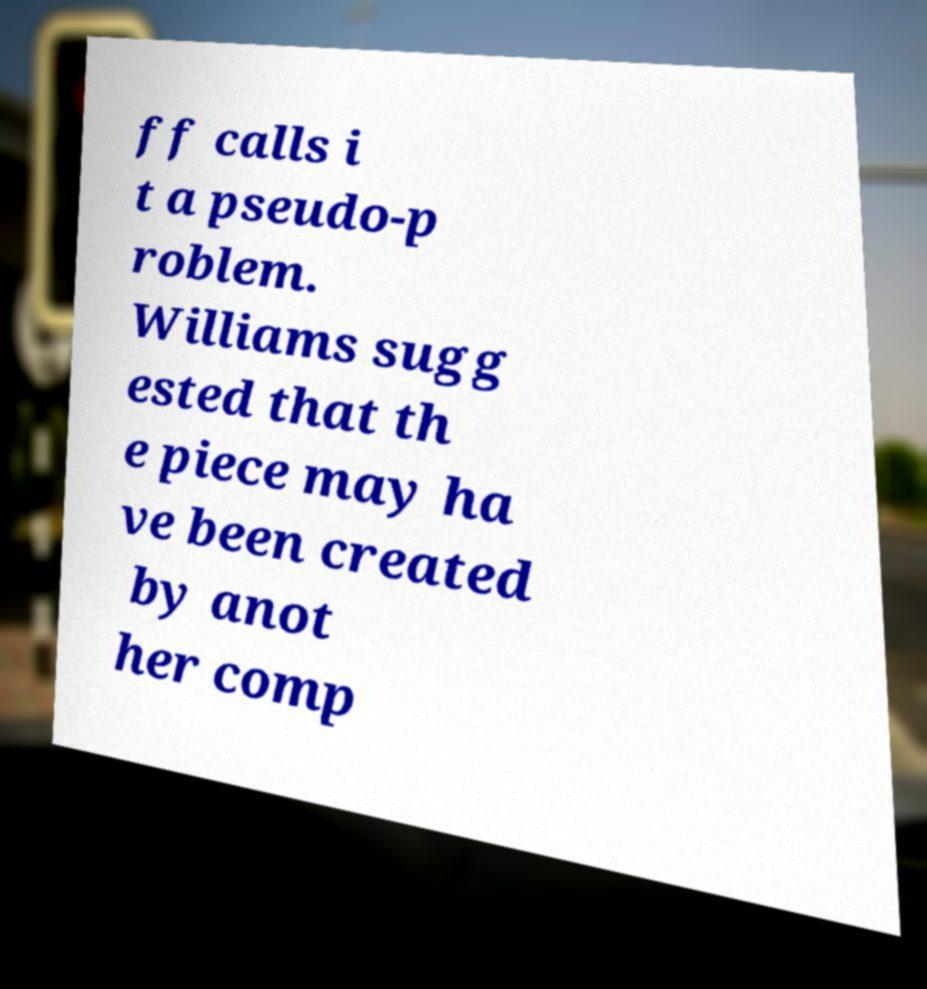Could you assist in decoding the text presented in this image and type it out clearly? ff calls i t a pseudo-p roblem. Williams sugg ested that th e piece may ha ve been created by anot her comp 